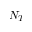Convert formula to latex. <formula><loc_0><loc_0><loc_500><loc_500>N _ { T }</formula> 